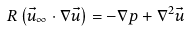<formula> <loc_0><loc_0><loc_500><loc_500>R \left ( \vec { u } _ { \infty } \cdot \nabla \vec { u } \right ) = - \nabla p + \nabla ^ { 2 } \vec { u }</formula> 